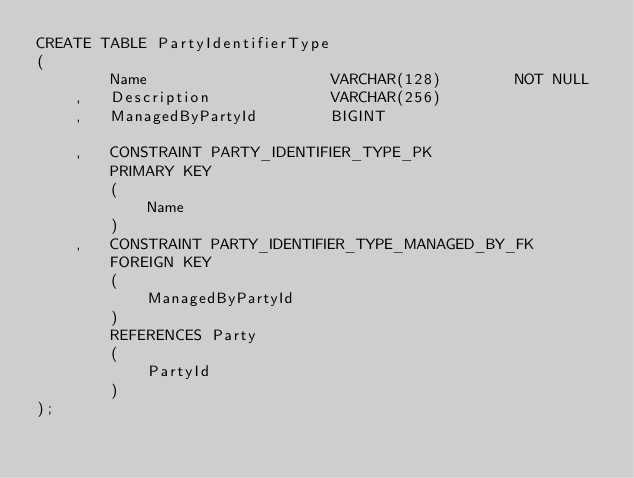<code> <loc_0><loc_0><loc_500><loc_500><_SQL_>CREATE TABLE PartyIdentifierType
(
		Name					VARCHAR(128)		NOT NULL
	,	Description				VARCHAR(256)
	,	ManagedByPartyId		BIGINT

	,	CONSTRAINT PARTY_IDENTIFIER_TYPE_PK
		PRIMARY KEY
		(
			Name
		)
	,	CONSTRAINT PARTY_IDENTIFIER_TYPE_MANAGED_BY_FK
		FOREIGN KEY
		(
			ManagedByPartyId
		)
		REFERENCES Party
		(
			PartyId
		)
);</code> 